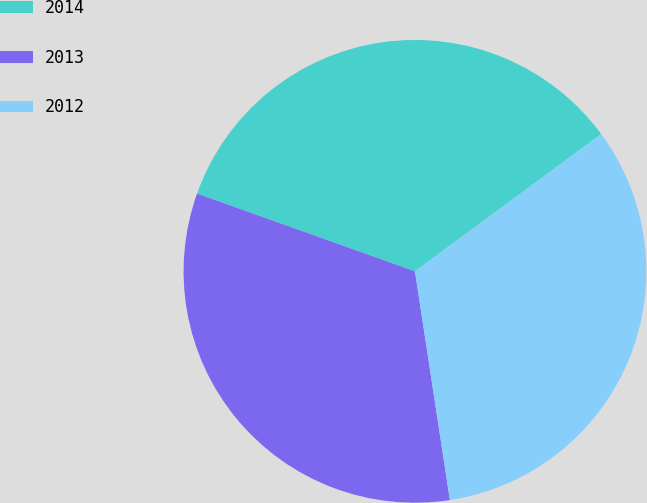Convert chart. <chart><loc_0><loc_0><loc_500><loc_500><pie_chart><fcel>2014<fcel>2013<fcel>2012<nl><fcel>34.44%<fcel>32.87%<fcel>32.7%<nl></chart> 